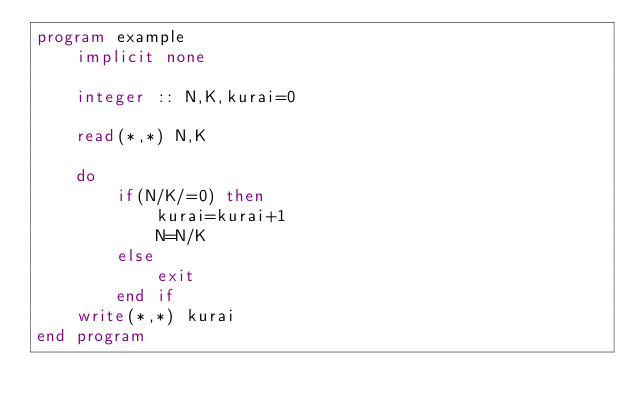Convert code to text. <code><loc_0><loc_0><loc_500><loc_500><_FORTRAN_>program example
	implicit none
    
    integer :: N,K,kurai=0
    
    read(*,*) N,K
    
    do
    	if(N/K/=0) then
        	kurai=kurai+1
            N=N/K
        else
        	exit
        end if
    write(*,*) kurai
end program</code> 